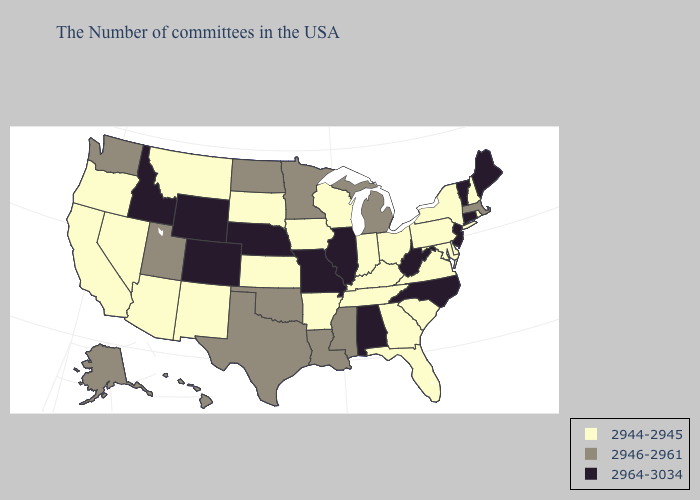Does Pennsylvania have the lowest value in the Northeast?
Quick response, please. Yes. What is the value of Montana?
Give a very brief answer. 2944-2945. What is the highest value in states that border Wisconsin?
Be succinct. 2964-3034. Does Vermont have the lowest value in the USA?
Be succinct. No. Name the states that have a value in the range 2946-2961?
Give a very brief answer. Massachusetts, Michigan, Mississippi, Louisiana, Minnesota, Oklahoma, Texas, North Dakota, Utah, Washington, Alaska, Hawaii. What is the value of North Carolina?
Write a very short answer. 2964-3034. What is the lowest value in the USA?
Concise answer only. 2944-2945. Name the states that have a value in the range 2946-2961?
Write a very short answer. Massachusetts, Michigan, Mississippi, Louisiana, Minnesota, Oklahoma, Texas, North Dakota, Utah, Washington, Alaska, Hawaii. Does Maine have the lowest value in the Northeast?
Quick response, please. No. Among the states that border South Carolina , does North Carolina have the lowest value?
Short answer required. No. Among the states that border Kentucky , does Virginia have the highest value?
Keep it brief. No. Does North Carolina have a higher value than Alabama?
Give a very brief answer. No. What is the value of West Virginia?
Concise answer only. 2964-3034. Does the map have missing data?
Quick response, please. No. Among the states that border Iowa , does Illinois have the highest value?
Write a very short answer. Yes. 